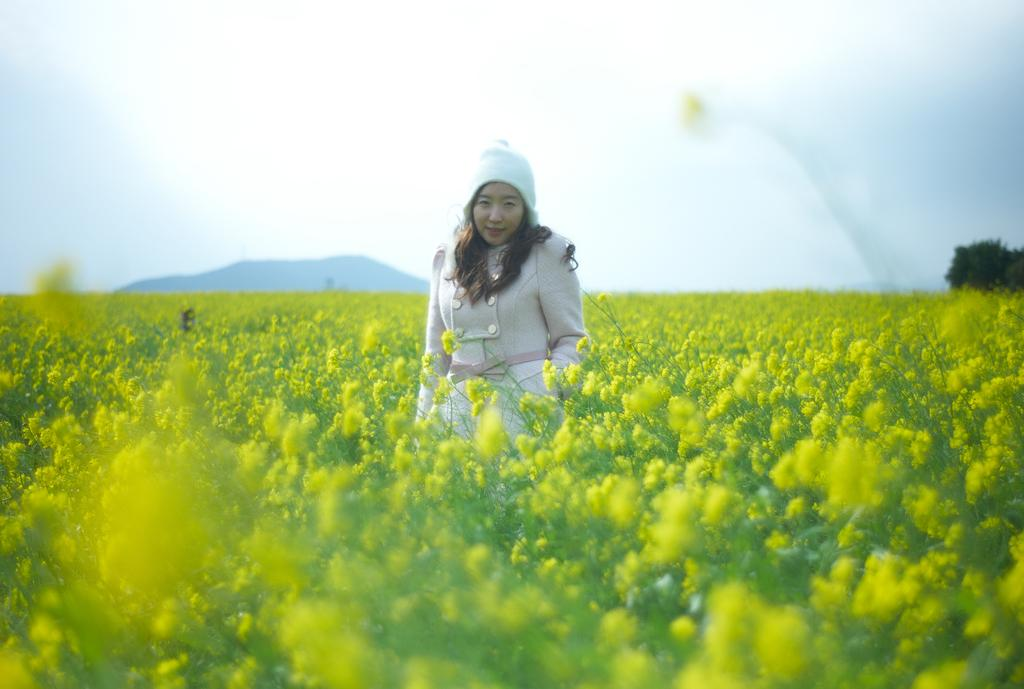Who is present in the image? There is a woman in the image. What is the setting of the image? The woman is standing in a flower garden. How is the flower garden described? The flower garden is described as beautiful. What can be seen in the background of the image? There is a mountain in the background of the image. What type of vegetation is on the right side of the image? There are trees on the right side of the image. What type of toy can be seen in the woman's hand in the image? There is no toy present in the woman's hand or in the image. 